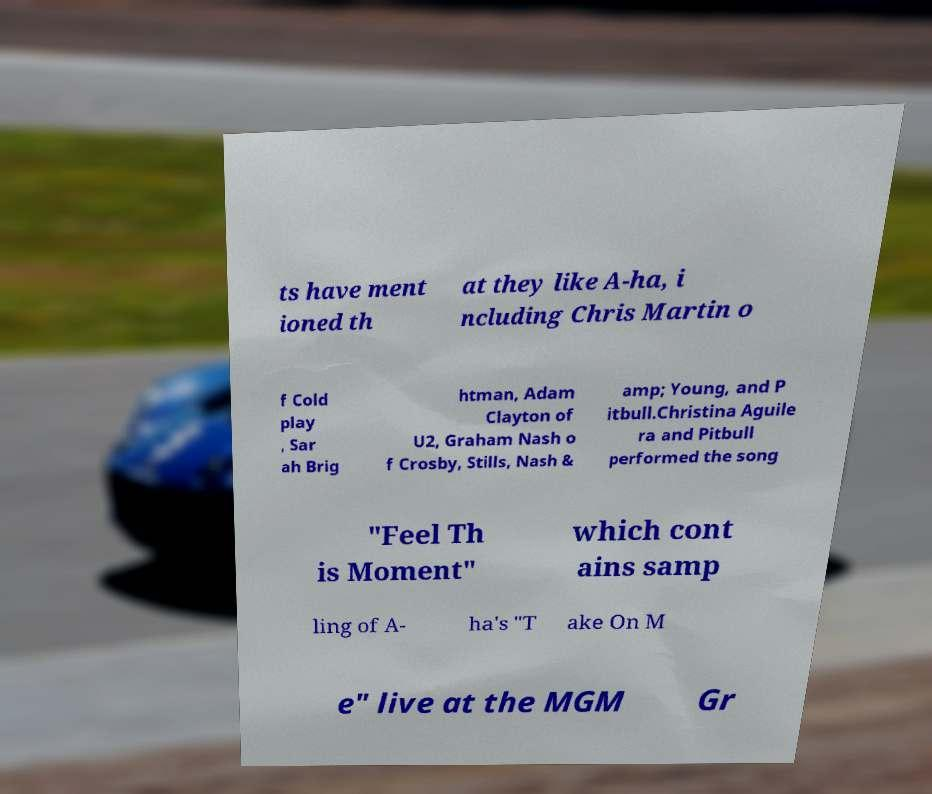For documentation purposes, I need the text within this image transcribed. Could you provide that? ts have ment ioned th at they like A-ha, i ncluding Chris Martin o f Cold play , Sar ah Brig htman, Adam Clayton of U2, Graham Nash o f Crosby, Stills, Nash & amp; Young, and P itbull.Christina Aguile ra and Pitbull performed the song "Feel Th is Moment" which cont ains samp ling of A- ha's "T ake On M e" live at the MGM Gr 